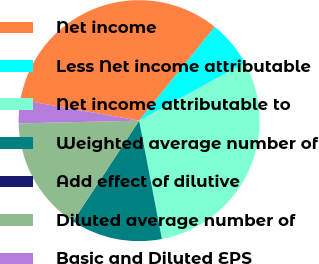Convert chart to OTSL. <chart><loc_0><loc_0><loc_500><loc_500><pie_chart><fcel>Net income<fcel>Less Net income attributable<fcel>Net income attributable to<fcel>Weighted average number of<fcel>Add effect of dilutive<fcel>Diluted average number of<fcel>Basic and Diluted EPS<nl><fcel>33.02%<fcel>6.26%<fcel>29.91%<fcel>12.26%<fcel>0.03%<fcel>15.37%<fcel>3.15%<nl></chart> 